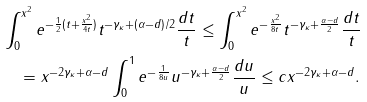<formula> <loc_0><loc_0><loc_500><loc_500>& \int _ { 0 } ^ { \| x \| ^ { 2 } } e ^ { - \frac { 1 } { 2 } ( t + \frac { \| x \| ^ { 2 } } { 4 t } ) } t ^ { - \gamma _ { \kappa } + ( \alpha - d ) / 2 } \frac { d t } { t } \leq \int _ { 0 } ^ { \| x \| ^ { 2 } } e ^ { - \frac { \| x \| ^ { 2 } } { 8 t } } t ^ { - \gamma _ { \kappa } + \frac { \alpha - d } { 2 } } \frac { d t } { t } \\ & \quad = \| x \| ^ { - 2 \gamma _ { \kappa } + \alpha - d } \int _ { 0 } ^ { 1 } e ^ { - \frac { 1 } { 8 u } } u ^ { - \gamma _ { \kappa } + \frac { \alpha - d } { 2 } } \frac { d u } { u } \leq c \| x \| ^ { - 2 \gamma _ { \kappa } + \alpha - d } .</formula> 